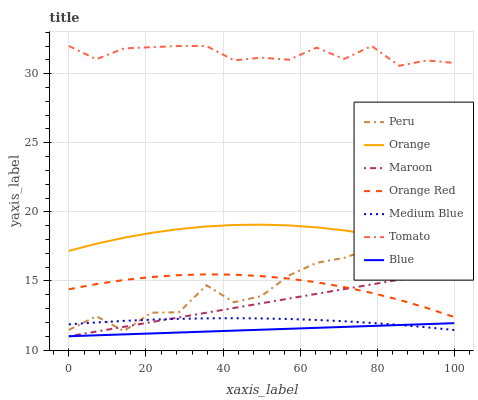Does Blue have the minimum area under the curve?
Answer yes or no. Yes. Does Tomato have the maximum area under the curve?
Answer yes or no. Yes. Does Medium Blue have the minimum area under the curve?
Answer yes or no. No. Does Medium Blue have the maximum area under the curve?
Answer yes or no. No. Is Blue the smoothest?
Answer yes or no. Yes. Is Peru the roughest?
Answer yes or no. Yes. Is Medium Blue the smoothest?
Answer yes or no. No. Is Medium Blue the roughest?
Answer yes or no. No. Does Blue have the lowest value?
Answer yes or no. Yes. Does Medium Blue have the lowest value?
Answer yes or no. No. Does Tomato have the highest value?
Answer yes or no. Yes. Does Medium Blue have the highest value?
Answer yes or no. No. Is Maroon less than Orange?
Answer yes or no. Yes. Is Tomato greater than Orange?
Answer yes or no. Yes. Does Maroon intersect Peru?
Answer yes or no. Yes. Is Maroon less than Peru?
Answer yes or no. No. Is Maroon greater than Peru?
Answer yes or no. No. Does Maroon intersect Orange?
Answer yes or no. No. 